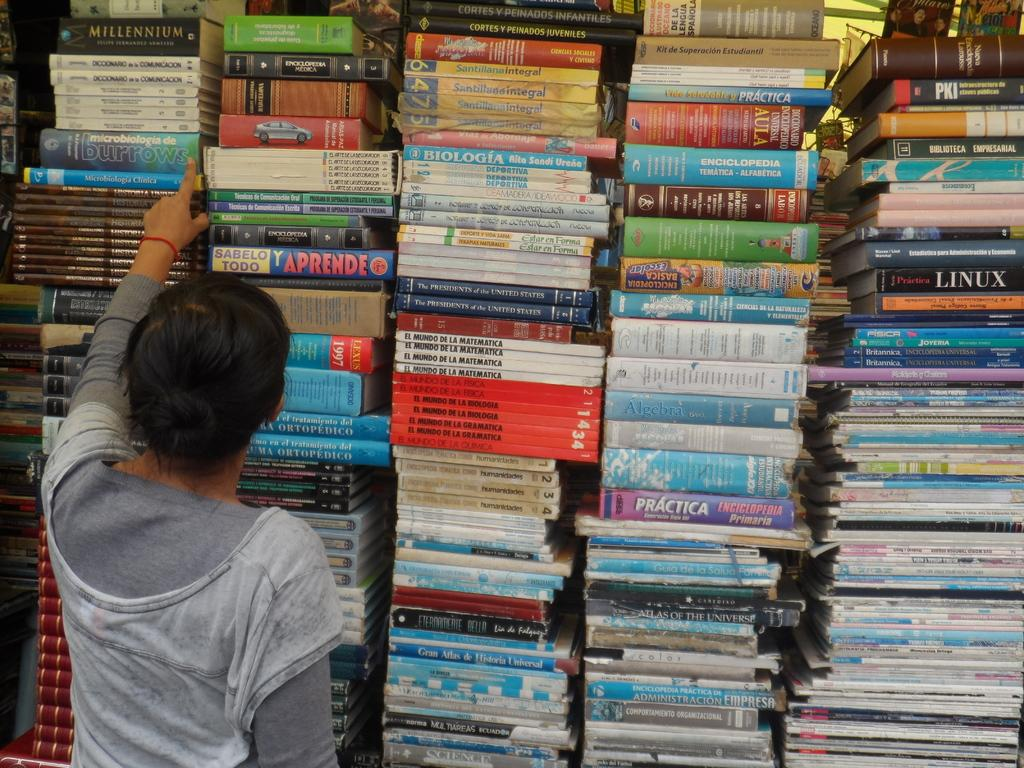<image>
Summarize the visual content of the image. Lots of stacked books including "Linux", "Biologia", and "Ptactica" 